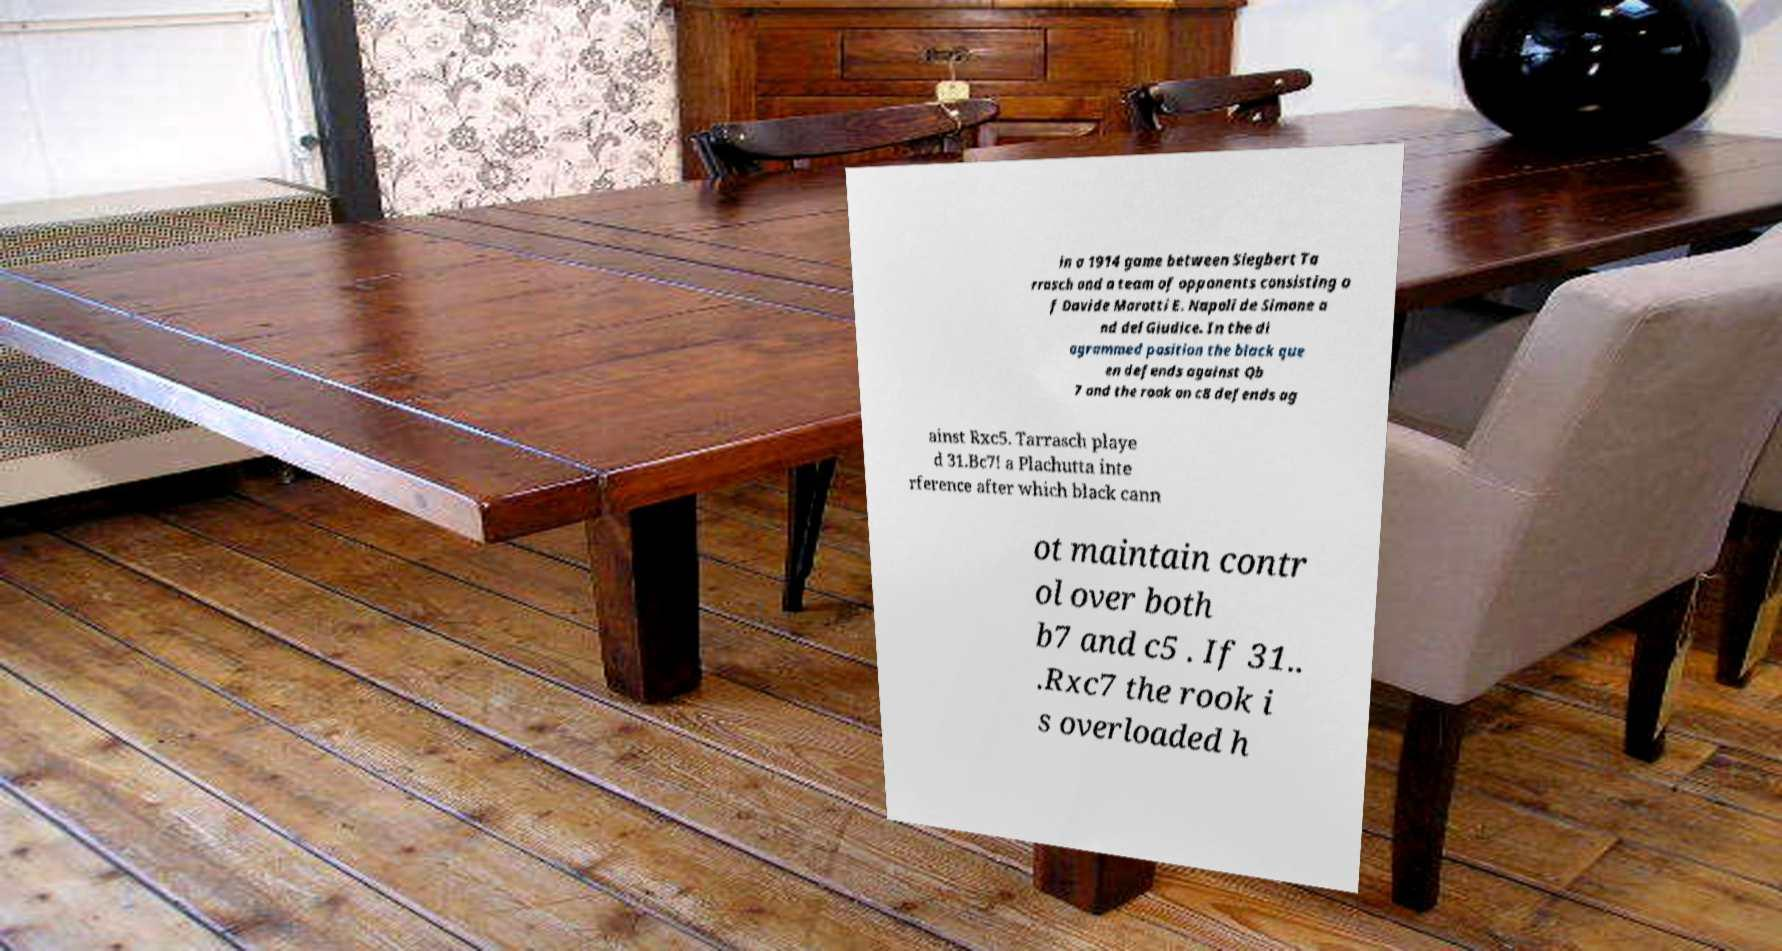Could you extract and type out the text from this image? in a 1914 game between Siegbert Ta rrasch and a team of opponents consisting o f Davide Marotti E. Napoli de Simone a nd del Giudice. In the di agrammed position the black que en defends against Qb 7 and the rook on c8 defends ag ainst Rxc5. Tarrasch playe d 31.Bc7! a Plachutta inte rference after which black cann ot maintain contr ol over both b7 and c5 . If 31.. .Rxc7 the rook i s overloaded h 